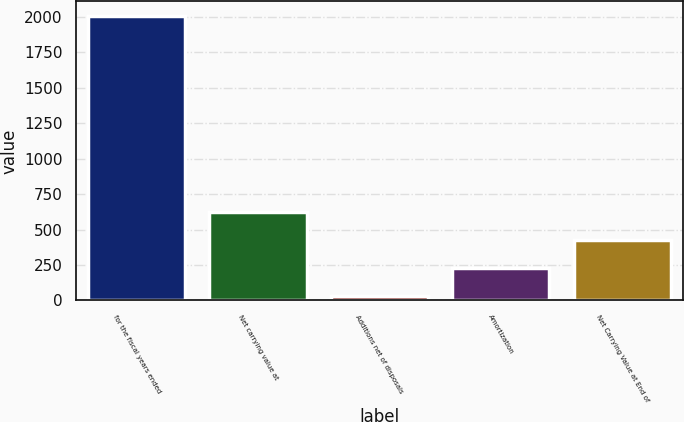Convert chart to OTSL. <chart><loc_0><loc_0><loc_500><loc_500><bar_chart><fcel>for the fiscal years ended<fcel>Net carrying value at<fcel>Additions net of disposals<fcel>Amortization<fcel>Net Carrying Value at End of<nl><fcel>2010<fcel>626.8<fcel>34<fcel>231.6<fcel>429.2<nl></chart> 